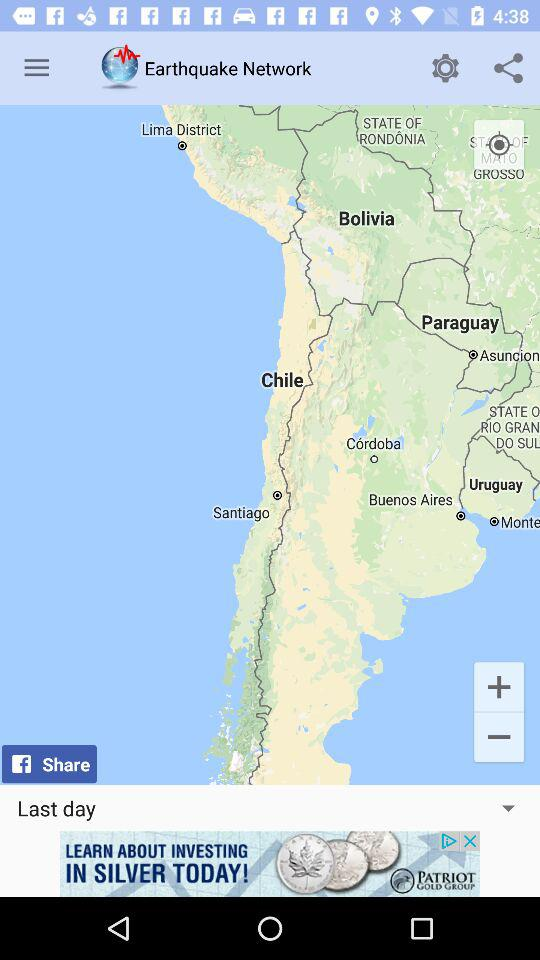What is the name of the application? The name of the application is "Earthquake Network". 